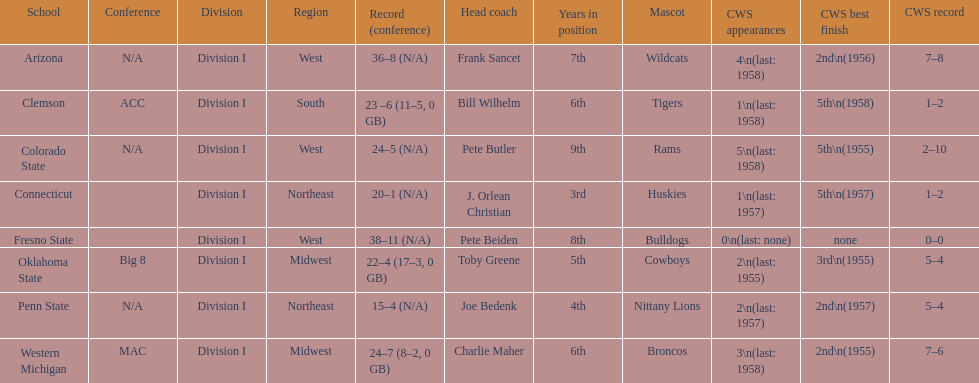What are the number of schools with more than 2 cws appearances? 3. 